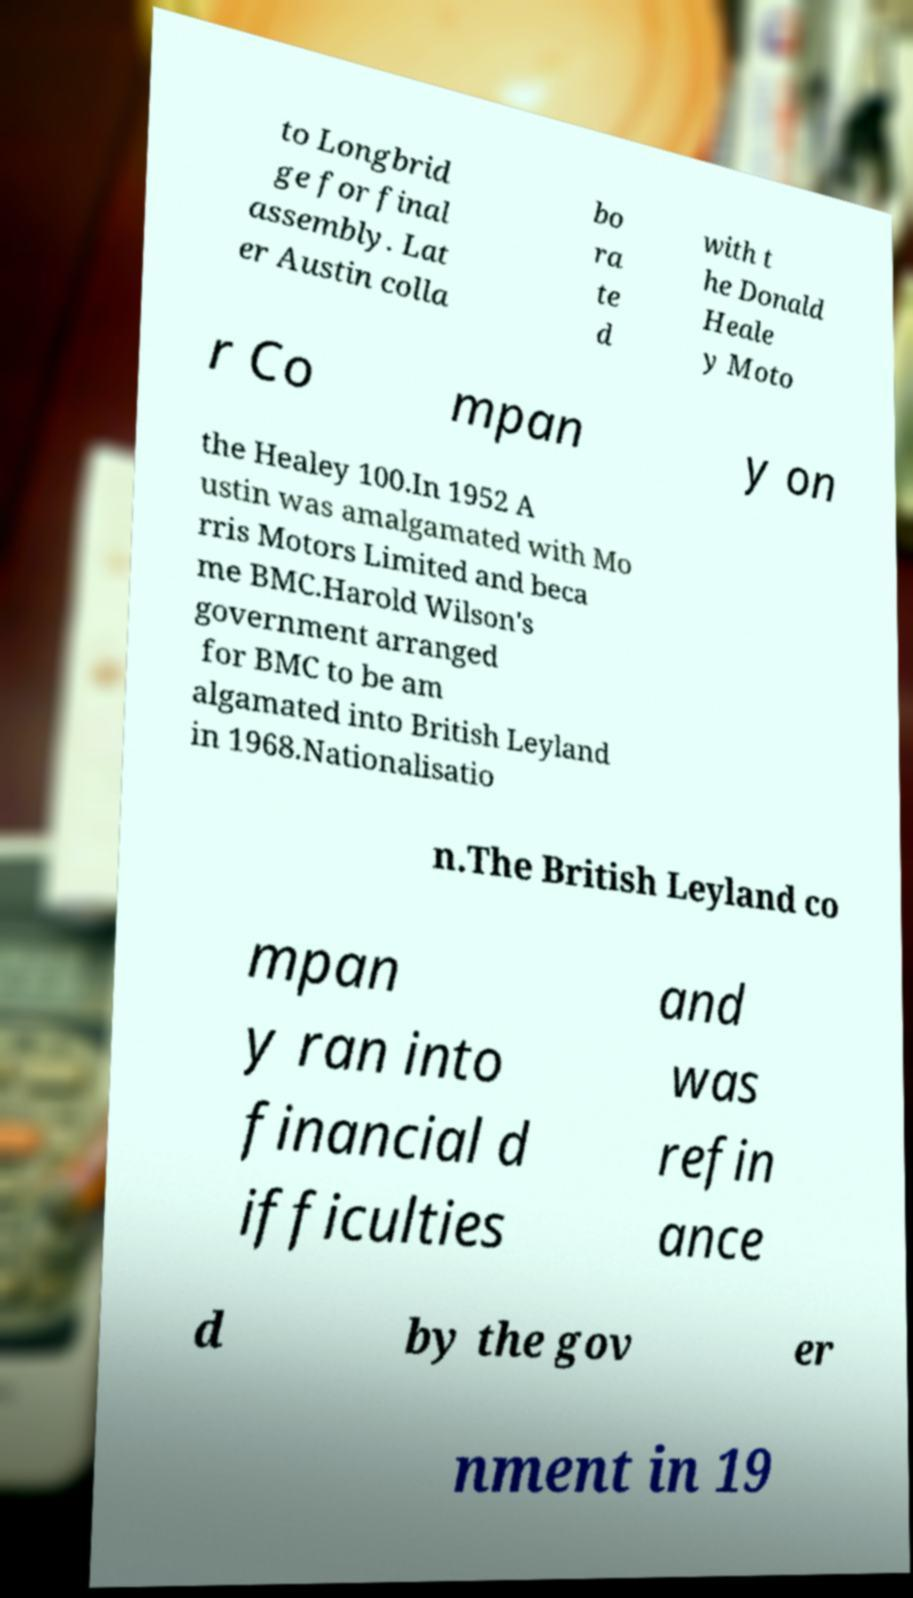Could you extract and type out the text from this image? to Longbrid ge for final assembly. Lat er Austin colla bo ra te d with t he Donald Heale y Moto r Co mpan y on the Healey 100.In 1952 A ustin was amalgamated with Mo rris Motors Limited and beca me BMC.Harold Wilson's government arranged for BMC to be am algamated into British Leyland in 1968.Nationalisatio n.The British Leyland co mpan y ran into financial d ifficulties and was refin ance d by the gov er nment in 19 